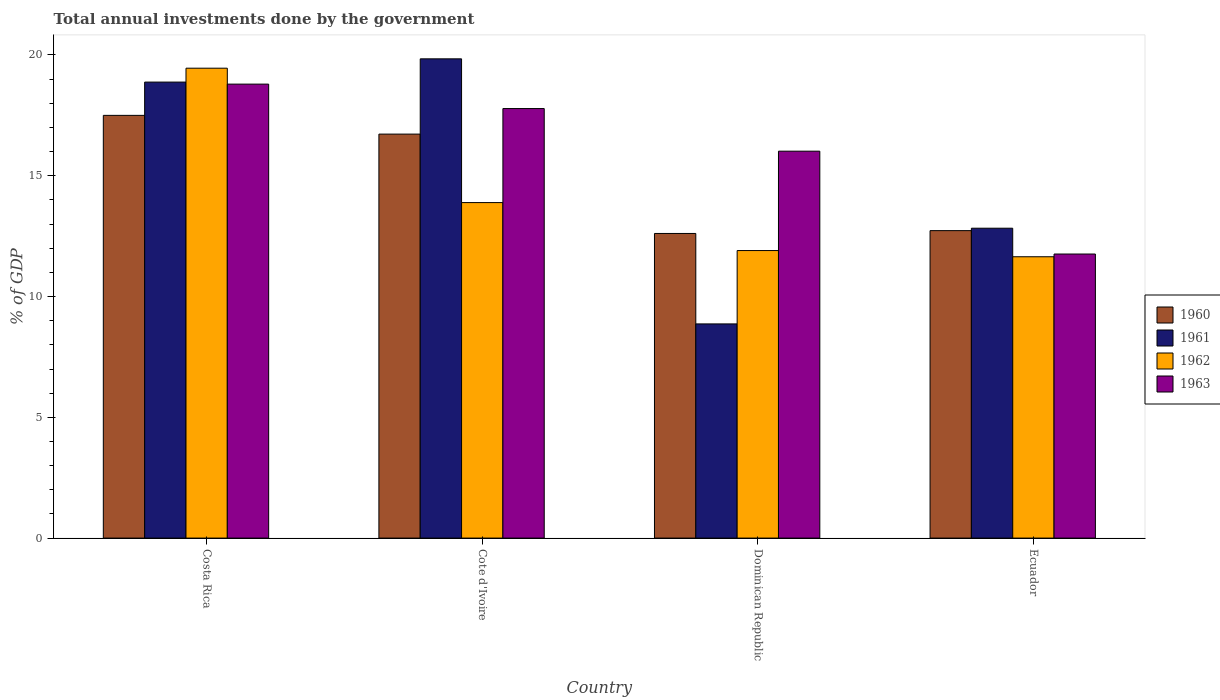How many different coloured bars are there?
Give a very brief answer. 4. Are the number of bars on each tick of the X-axis equal?
Provide a short and direct response. Yes. What is the label of the 4th group of bars from the left?
Provide a short and direct response. Ecuador. What is the total annual investments done by the government in 1962 in Cote d'Ivoire?
Offer a terse response. 13.89. Across all countries, what is the maximum total annual investments done by the government in 1963?
Give a very brief answer. 18.79. Across all countries, what is the minimum total annual investments done by the government in 1962?
Give a very brief answer. 11.65. In which country was the total annual investments done by the government in 1961 maximum?
Offer a terse response. Cote d'Ivoire. In which country was the total annual investments done by the government in 1963 minimum?
Offer a terse response. Ecuador. What is the total total annual investments done by the government in 1960 in the graph?
Make the answer very short. 59.57. What is the difference between the total annual investments done by the government in 1961 in Costa Rica and that in Ecuador?
Offer a terse response. 6.05. What is the difference between the total annual investments done by the government in 1960 in Dominican Republic and the total annual investments done by the government in 1961 in Costa Rica?
Your answer should be compact. -6.27. What is the average total annual investments done by the government in 1963 per country?
Your response must be concise. 16.09. What is the difference between the total annual investments done by the government of/in 1961 and total annual investments done by the government of/in 1960 in Ecuador?
Provide a succinct answer. 0.1. In how many countries, is the total annual investments done by the government in 1962 greater than 10 %?
Give a very brief answer. 4. What is the ratio of the total annual investments done by the government in 1960 in Cote d'Ivoire to that in Dominican Republic?
Give a very brief answer. 1.33. Is the difference between the total annual investments done by the government in 1961 in Costa Rica and Dominican Republic greater than the difference between the total annual investments done by the government in 1960 in Costa Rica and Dominican Republic?
Offer a very short reply. Yes. What is the difference between the highest and the second highest total annual investments done by the government in 1963?
Give a very brief answer. -1.76. What is the difference between the highest and the lowest total annual investments done by the government in 1963?
Provide a short and direct response. 7.03. Is the sum of the total annual investments done by the government in 1960 in Dominican Republic and Ecuador greater than the maximum total annual investments done by the government in 1962 across all countries?
Your answer should be compact. Yes. Is it the case that in every country, the sum of the total annual investments done by the government in 1960 and total annual investments done by the government in 1963 is greater than the sum of total annual investments done by the government in 1961 and total annual investments done by the government in 1962?
Ensure brevity in your answer.  No. Is it the case that in every country, the sum of the total annual investments done by the government in 1962 and total annual investments done by the government in 1960 is greater than the total annual investments done by the government in 1963?
Your answer should be very brief. Yes. Does the graph contain any zero values?
Keep it short and to the point. No. Does the graph contain grids?
Offer a very short reply. No. What is the title of the graph?
Your response must be concise. Total annual investments done by the government. Does "1984" appear as one of the legend labels in the graph?
Ensure brevity in your answer.  No. What is the label or title of the Y-axis?
Ensure brevity in your answer.  % of GDP. What is the % of GDP of 1960 in Costa Rica?
Your answer should be very brief. 17.5. What is the % of GDP of 1961 in Costa Rica?
Your answer should be very brief. 18.88. What is the % of GDP in 1962 in Costa Rica?
Make the answer very short. 19.45. What is the % of GDP in 1963 in Costa Rica?
Keep it short and to the point. 18.79. What is the % of GDP in 1960 in Cote d'Ivoire?
Offer a terse response. 16.72. What is the % of GDP of 1961 in Cote d'Ivoire?
Your answer should be very brief. 19.84. What is the % of GDP of 1962 in Cote d'Ivoire?
Give a very brief answer. 13.89. What is the % of GDP in 1963 in Cote d'Ivoire?
Make the answer very short. 17.78. What is the % of GDP in 1960 in Dominican Republic?
Your response must be concise. 12.61. What is the % of GDP of 1961 in Dominican Republic?
Give a very brief answer. 8.87. What is the % of GDP of 1962 in Dominican Republic?
Your answer should be very brief. 11.9. What is the % of GDP in 1963 in Dominican Republic?
Ensure brevity in your answer.  16.02. What is the % of GDP of 1960 in Ecuador?
Your response must be concise. 12.73. What is the % of GDP in 1961 in Ecuador?
Make the answer very short. 12.83. What is the % of GDP of 1962 in Ecuador?
Offer a very short reply. 11.65. What is the % of GDP in 1963 in Ecuador?
Your response must be concise. 11.76. Across all countries, what is the maximum % of GDP in 1960?
Your answer should be very brief. 17.5. Across all countries, what is the maximum % of GDP in 1961?
Provide a short and direct response. 19.84. Across all countries, what is the maximum % of GDP of 1962?
Give a very brief answer. 19.45. Across all countries, what is the maximum % of GDP in 1963?
Keep it short and to the point. 18.79. Across all countries, what is the minimum % of GDP of 1960?
Your answer should be very brief. 12.61. Across all countries, what is the minimum % of GDP of 1961?
Your answer should be compact. 8.87. Across all countries, what is the minimum % of GDP in 1962?
Give a very brief answer. 11.65. Across all countries, what is the minimum % of GDP in 1963?
Offer a very short reply. 11.76. What is the total % of GDP of 1960 in the graph?
Your answer should be very brief. 59.57. What is the total % of GDP in 1961 in the graph?
Provide a short and direct response. 60.42. What is the total % of GDP of 1962 in the graph?
Offer a very short reply. 56.89. What is the total % of GDP of 1963 in the graph?
Your answer should be very brief. 64.36. What is the difference between the % of GDP in 1960 in Costa Rica and that in Cote d'Ivoire?
Give a very brief answer. 0.78. What is the difference between the % of GDP in 1961 in Costa Rica and that in Cote d'Ivoire?
Offer a very short reply. -0.96. What is the difference between the % of GDP in 1962 in Costa Rica and that in Cote d'Ivoire?
Your answer should be compact. 5.56. What is the difference between the % of GDP of 1963 in Costa Rica and that in Cote d'Ivoire?
Make the answer very short. 1.01. What is the difference between the % of GDP in 1960 in Costa Rica and that in Dominican Republic?
Provide a succinct answer. 4.89. What is the difference between the % of GDP in 1961 in Costa Rica and that in Dominican Republic?
Ensure brevity in your answer.  10.01. What is the difference between the % of GDP of 1962 in Costa Rica and that in Dominican Republic?
Ensure brevity in your answer.  7.55. What is the difference between the % of GDP of 1963 in Costa Rica and that in Dominican Republic?
Your answer should be compact. 2.78. What is the difference between the % of GDP of 1960 in Costa Rica and that in Ecuador?
Offer a terse response. 4.77. What is the difference between the % of GDP of 1961 in Costa Rica and that in Ecuador?
Provide a short and direct response. 6.05. What is the difference between the % of GDP of 1962 in Costa Rica and that in Ecuador?
Your response must be concise. 7.81. What is the difference between the % of GDP of 1963 in Costa Rica and that in Ecuador?
Your answer should be compact. 7.03. What is the difference between the % of GDP in 1960 in Cote d'Ivoire and that in Dominican Republic?
Offer a terse response. 4.11. What is the difference between the % of GDP in 1961 in Cote d'Ivoire and that in Dominican Republic?
Offer a very short reply. 10.97. What is the difference between the % of GDP of 1962 in Cote d'Ivoire and that in Dominican Republic?
Offer a terse response. 1.99. What is the difference between the % of GDP of 1963 in Cote d'Ivoire and that in Dominican Republic?
Your answer should be compact. 1.76. What is the difference between the % of GDP of 1960 in Cote d'Ivoire and that in Ecuador?
Your response must be concise. 4. What is the difference between the % of GDP of 1961 in Cote d'Ivoire and that in Ecuador?
Provide a short and direct response. 7.01. What is the difference between the % of GDP in 1962 in Cote d'Ivoire and that in Ecuador?
Your answer should be very brief. 2.24. What is the difference between the % of GDP in 1963 in Cote d'Ivoire and that in Ecuador?
Your answer should be very brief. 6.02. What is the difference between the % of GDP in 1960 in Dominican Republic and that in Ecuador?
Offer a very short reply. -0.12. What is the difference between the % of GDP of 1961 in Dominican Republic and that in Ecuador?
Keep it short and to the point. -3.96. What is the difference between the % of GDP of 1962 in Dominican Republic and that in Ecuador?
Keep it short and to the point. 0.26. What is the difference between the % of GDP in 1963 in Dominican Republic and that in Ecuador?
Your response must be concise. 4.26. What is the difference between the % of GDP in 1960 in Costa Rica and the % of GDP in 1961 in Cote d'Ivoire?
Your answer should be compact. -2.34. What is the difference between the % of GDP in 1960 in Costa Rica and the % of GDP in 1962 in Cote d'Ivoire?
Your answer should be very brief. 3.61. What is the difference between the % of GDP of 1960 in Costa Rica and the % of GDP of 1963 in Cote d'Ivoire?
Provide a succinct answer. -0.28. What is the difference between the % of GDP in 1961 in Costa Rica and the % of GDP in 1962 in Cote d'Ivoire?
Provide a succinct answer. 4.99. What is the difference between the % of GDP in 1961 in Costa Rica and the % of GDP in 1963 in Cote d'Ivoire?
Your response must be concise. 1.1. What is the difference between the % of GDP of 1962 in Costa Rica and the % of GDP of 1963 in Cote d'Ivoire?
Provide a short and direct response. 1.67. What is the difference between the % of GDP in 1960 in Costa Rica and the % of GDP in 1961 in Dominican Republic?
Give a very brief answer. 8.63. What is the difference between the % of GDP of 1960 in Costa Rica and the % of GDP of 1962 in Dominican Republic?
Offer a very short reply. 5.6. What is the difference between the % of GDP of 1960 in Costa Rica and the % of GDP of 1963 in Dominican Republic?
Offer a very short reply. 1.48. What is the difference between the % of GDP of 1961 in Costa Rica and the % of GDP of 1962 in Dominican Republic?
Provide a short and direct response. 6.97. What is the difference between the % of GDP of 1961 in Costa Rica and the % of GDP of 1963 in Dominican Republic?
Provide a short and direct response. 2.86. What is the difference between the % of GDP of 1962 in Costa Rica and the % of GDP of 1963 in Dominican Republic?
Provide a short and direct response. 3.44. What is the difference between the % of GDP of 1960 in Costa Rica and the % of GDP of 1961 in Ecuador?
Ensure brevity in your answer.  4.67. What is the difference between the % of GDP in 1960 in Costa Rica and the % of GDP in 1962 in Ecuador?
Keep it short and to the point. 5.85. What is the difference between the % of GDP in 1960 in Costa Rica and the % of GDP in 1963 in Ecuador?
Your response must be concise. 5.74. What is the difference between the % of GDP in 1961 in Costa Rica and the % of GDP in 1962 in Ecuador?
Your answer should be very brief. 7.23. What is the difference between the % of GDP in 1961 in Costa Rica and the % of GDP in 1963 in Ecuador?
Your answer should be compact. 7.12. What is the difference between the % of GDP in 1962 in Costa Rica and the % of GDP in 1963 in Ecuador?
Offer a very short reply. 7.69. What is the difference between the % of GDP in 1960 in Cote d'Ivoire and the % of GDP in 1961 in Dominican Republic?
Your response must be concise. 7.86. What is the difference between the % of GDP of 1960 in Cote d'Ivoire and the % of GDP of 1962 in Dominican Republic?
Your answer should be compact. 4.82. What is the difference between the % of GDP in 1960 in Cote d'Ivoire and the % of GDP in 1963 in Dominican Republic?
Keep it short and to the point. 0.71. What is the difference between the % of GDP in 1961 in Cote d'Ivoire and the % of GDP in 1962 in Dominican Republic?
Give a very brief answer. 7.94. What is the difference between the % of GDP in 1961 in Cote d'Ivoire and the % of GDP in 1963 in Dominican Republic?
Ensure brevity in your answer.  3.82. What is the difference between the % of GDP of 1962 in Cote d'Ivoire and the % of GDP of 1963 in Dominican Republic?
Offer a terse response. -2.13. What is the difference between the % of GDP in 1960 in Cote d'Ivoire and the % of GDP in 1961 in Ecuador?
Offer a terse response. 3.9. What is the difference between the % of GDP of 1960 in Cote d'Ivoire and the % of GDP of 1962 in Ecuador?
Provide a succinct answer. 5.08. What is the difference between the % of GDP of 1960 in Cote d'Ivoire and the % of GDP of 1963 in Ecuador?
Offer a very short reply. 4.96. What is the difference between the % of GDP of 1961 in Cote d'Ivoire and the % of GDP of 1962 in Ecuador?
Offer a very short reply. 8.19. What is the difference between the % of GDP of 1961 in Cote d'Ivoire and the % of GDP of 1963 in Ecuador?
Keep it short and to the point. 8.08. What is the difference between the % of GDP of 1962 in Cote d'Ivoire and the % of GDP of 1963 in Ecuador?
Give a very brief answer. 2.13. What is the difference between the % of GDP of 1960 in Dominican Republic and the % of GDP of 1961 in Ecuador?
Provide a short and direct response. -0.22. What is the difference between the % of GDP of 1960 in Dominican Republic and the % of GDP of 1962 in Ecuador?
Your answer should be compact. 0.96. What is the difference between the % of GDP of 1960 in Dominican Republic and the % of GDP of 1963 in Ecuador?
Your answer should be very brief. 0.85. What is the difference between the % of GDP in 1961 in Dominican Republic and the % of GDP in 1962 in Ecuador?
Provide a short and direct response. -2.78. What is the difference between the % of GDP in 1961 in Dominican Republic and the % of GDP in 1963 in Ecuador?
Your answer should be compact. -2.89. What is the difference between the % of GDP in 1962 in Dominican Republic and the % of GDP in 1963 in Ecuador?
Ensure brevity in your answer.  0.14. What is the average % of GDP in 1960 per country?
Ensure brevity in your answer.  14.89. What is the average % of GDP of 1961 per country?
Give a very brief answer. 15.1. What is the average % of GDP in 1962 per country?
Keep it short and to the point. 14.22. What is the average % of GDP in 1963 per country?
Provide a short and direct response. 16.09. What is the difference between the % of GDP in 1960 and % of GDP in 1961 in Costa Rica?
Provide a succinct answer. -1.38. What is the difference between the % of GDP of 1960 and % of GDP of 1962 in Costa Rica?
Your answer should be compact. -1.95. What is the difference between the % of GDP of 1960 and % of GDP of 1963 in Costa Rica?
Ensure brevity in your answer.  -1.29. What is the difference between the % of GDP in 1961 and % of GDP in 1962 in Costa Rica?
Your response must be concise. -0.58. What is the difference between the % of GDP of 1961 and % of GDP of 1963 in Costa Rica?
Keep it short and to the point. 0.08. What is the difference between the % of GDP in 1962 and % of GDP in 1963 in Costa Rica?
Your answer should be very brief. 0.66. What is the difference between the % of GDP in 1960 and % of GDP in 1961 in Cote d'Ivoire?
Ensure brevity in your answer.  -3.12. What is the difference between the % of GDP of 1960 and % of GDP of 1962 in Cote d'Ivoire?
Keep it short and to the point. 2.84. What is the difference between the % of GDP of 1960 and % of GDP of 1963 in Cote d'Ivoire?
Offer a terse response. -1.06. What is the difference between the % of GDP in 1961 and % of GDP in 1962 in Cote d'Ivoire?
Provide a short and direct response. 5.95. What is the difference between the % of GDP of 1961 and % of GDP of 1963 in Cote d'Ivoire?
Keep it short and to the point. 2.06. What is the difference between the % of GDP of 1962 and % of GDP of 1963 in Cote d'Ivoire?
Ensure brevity in your answer.  -3.89. What is the difference between the % of GDP of 1960 and % of GDP of 1961 in Dominican Republic?
Your answer should be compact. 3.74. What is the difference between the % of GDP of 1960 and % of GDP of 1962 in Dominican Republic?
Your answer should be very brief. 0.71. What is the difference between the % of GDP of 1960 and % of GDP of 1963 in Dominican Republic?
Keep it short and to the point. -3.41. What is the difference between the % of GDP of 1961 and % of GDP of 1962 in Dominican Republic?
Offer a terse response. -3.04. What is the difference between the % of GDP in 1961 and % of GDP in 1963 in Dominican Republic?
Your response must be concise. -7.15. What is the difference between the % of GDP in 1962 and % of GDP in 1963 in Dominican Republic?
Your answer should be very brief. -4.11. What is the difference between the % of GDP of 1960 and % of GDP of 1961 in Ecuador?
Offer a very short reply. -0.1. What is the difference between the % of GDP of 1960 and % of GDP of 1962 in Ecuador?
Keep it short and to the point. 1.08. What is the difference between the % of GDP in 1961 and % of GDP in 1962 in Ecuador?
Offer a very short reply. 1.18. What is the difference between the % of GDP in 1961 and % of GDP in 1963 in Ecuador?
Your answer should be compact. 1.07. What is the difference between the % of GDP in 1962 and % of GDP in 1963 in Ecuador?
Your answer should be compact. -0.11. What is the ratio of the % of GDP in 1960 in Costa Rica to that in Cote d'Ivoire?
Make the answer very short. 1.05. What is the ratio of the % of GDP in 1961 in Costa Rica to that in Cote d'Ivoire?
Give a very brief answer. 0.95. What is the ratio of the % of GDP of 1962 in Costa Rica to that in Cote d'Ivoire?
Your answer should be compact. 1.4. What is the ratio of the % of GDP in 1963 in Costa Rica to that in Cote d'Ivoire?
Ensure brevity in your answer.  1.06. What is the ratio of the % of GDP of 1960 in Costa Rica to that in Dominican Republic?
Your answer should be very brief. 1.39. What is the ratio of the % of GDP of 1961 in Costa Rica to that in Dominican Republic?
Keep it short and to the point. 2.13. What is the ratio of the % of GDP of 1962 in Costa Rica to that in Dominican Republic?
Your answer should be very brief. 1.63. What is the ratio of the % of GDP of 1963 in Costa Rica to that in Dominican Republic?
Give a very brief answer. 1.17. What is the ratio of the % of GDP of 1960 in Costa Rica to that in Ecuador?
Offer a very short reply. 1.37. What is the ratio of the % of GDP of 1961 in Costa Rica to that in Ecuador?
Provide a short and direct response. 1.47. What is the ratio of the % of GDP of 1962 in Costa Rica to that in Ecuador?
Offer a terse response. 1.67. What is the ratio of the % of GDP in 1963 in Costa Rica to that in Ecuador?
Give a very brief answer. 1.6. What is the ratio of the % of GDP in 1960 in Cote d'Ivoire to that in Dominican Republic?
Provide a short and direct response. 1.33. What is the ratio of the % of GDP in 1961 in Cote d'Ivoire to that in Dominican Republic?
Ensure brevity in your answer.  2.24. What is the ratio of the % of GDP of 1962 in Cote d'Ivoire to that in Dominican Republic?
Offer a terse response. 1.17. What is the ratio of the % of GDP of 1963 in Cote d'Ivoire to that in Dominican Republic?
Your answer should be very brief. 1.11. What is the ratio of the % of GDP in 1960 in Cote d'Ivoire to that in Ecuador?
Offer a terse response. 1.31. What is the ratio of the % of GDP in 1961 in Cote d'Ivoire to that in Ecuador?
Ensure brevity in your answer.  1.55. What is the ratio of the % of GDP of 1962 in Cote d'Ivoire to that in Ecuador?
Give a very brief answer. 1.19. What is the ratio of the % of GDP of 1963 in Cote d'Ivoire to that in Ecuador?
Provide a short and direct response. 1.51. What is the ratio of the % of GDP in 1960 in Dominican Republic to that in Ecuador?
Keep it short and to the point. 0.99. What is the ratio of the % of GDP in 1961 in Dominican Republic to that in Ecuador?
Your response must be concise. 0.69. What is the ratio of the % of GDP of 1962 in Dominican Republic to that in Ecuador?
Provide a succinct answer. 1.02. What is the ratio of the % of GDP of 1963 in Dominican Republic to that in Ecuador?
Ensure brevity in your answer.  1.36. What is the difference between the highest and the second highest % of GDP in 1960?
Offer a terse response. 0.78. What is the difference between the highest and the second highest % of GDP in 1961?
Your answer should be compact. 0.96. What is the difference between the highest and the second highest % of GDP in 1962?
Keep it short and to the point. 5.56. What is the difference between the highest and the second highest % of GDP in 1963?
Your answer should be very brief. 1.01. What is the difference between the highest and the lowest % of GDP of 1960?
Ensure brevity in your answer.  4.89. What is the difference between the highest and the lowest % of GDP of 1961?
Keep it short and to the point. 10.97. What is the difference between the highest and the lowest % of GDP of 1962?
Offer a very short reply. 7.81. What is the difference between the highest and the lowest % of GDP in 1963?
Offer a terse response. 7.03. 